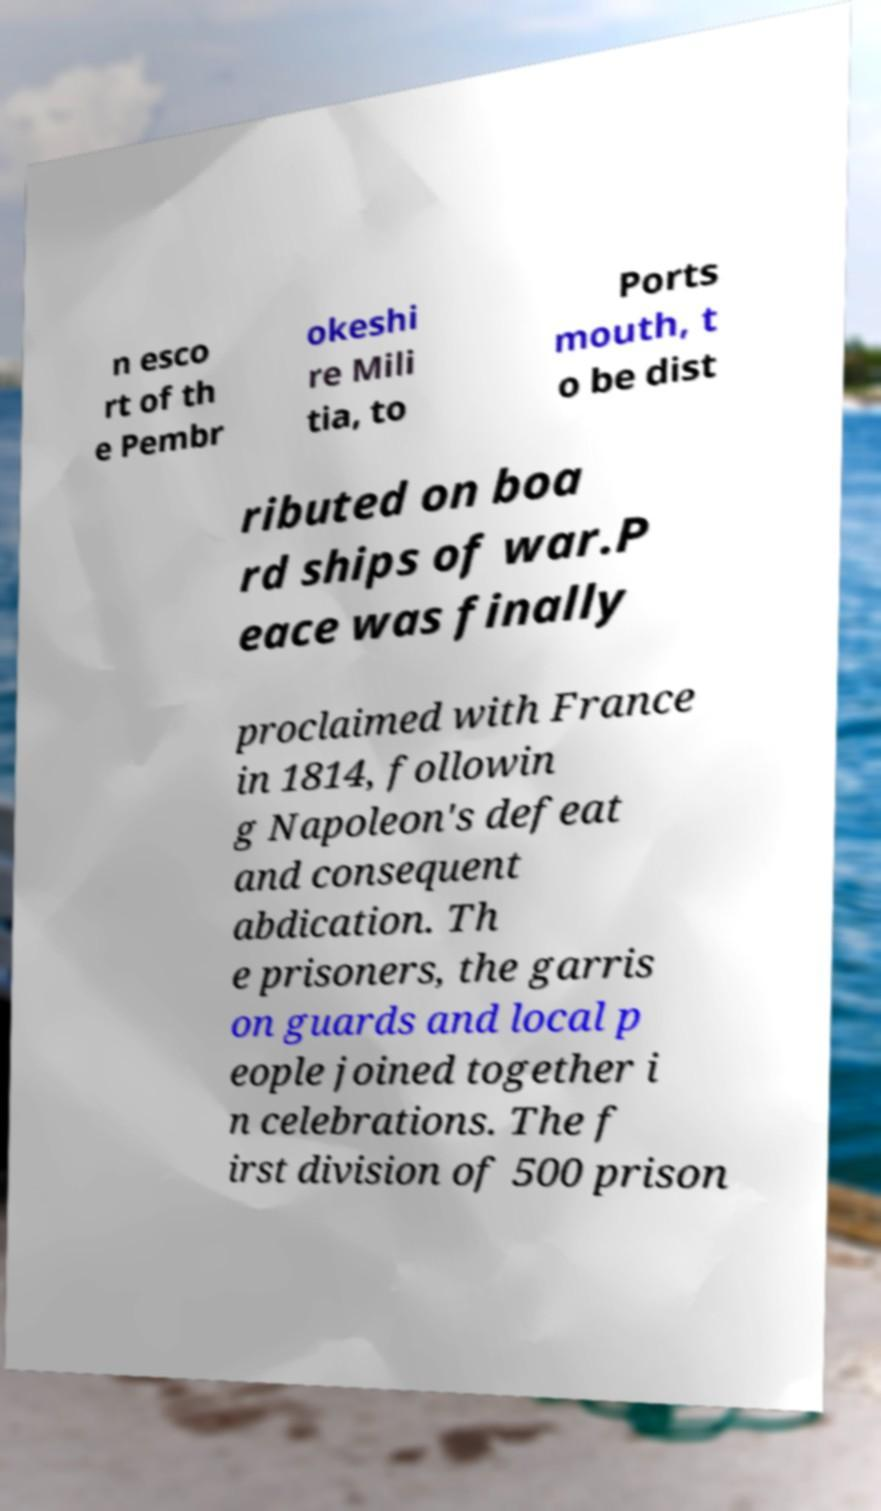For documentation purposes, I need the text within this image transcribed. Could you provide that? n esco rt of th e Pembr okeshi re Mili tia, to Ports mouth, t o be dist ributed on boa rd ships of war.P eace was finally proclaimed with France in 1814, followin g Napoleon's defeat and consequent abdication. Th e prisoners, the garris on guards and local p eople joined together i n celebrations. The f irst division of 500 prison 